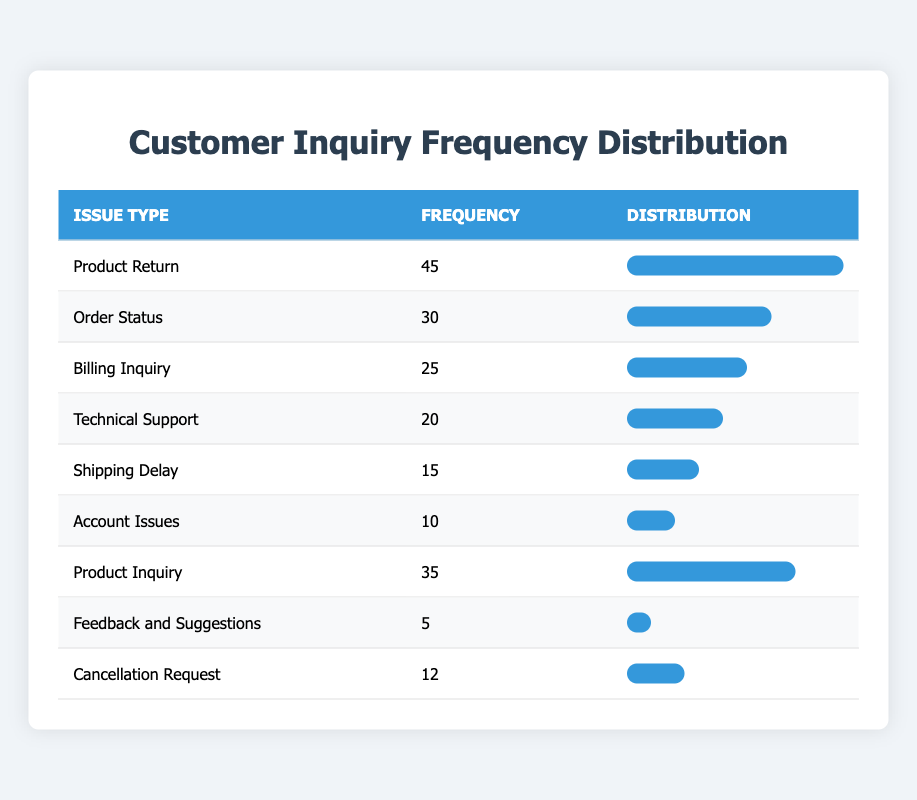What issue type has the highest frequency? By analyzing the table, we see that "Product Return" has a frequency of 45, which is the highest among all issue types listed.
Answer: Product Return How many inquiries were related to "Technical Support"? According to the table, "Technical Support" has a frequency of 20, which directly answers the question.
Answer: 20 What is the total frequency of all customer inquiries? To find the total frequency, we need to sum up all the frequencies: 45 + 30 + 25 + 20 + 15 + 10 + 35 + 5 + 12 = 192. Thus, the total frequency is 192.
Answer: 192 Is there a higher frequency of "Product Inquiry" than "Order Status"? The table indicates that "Product Inquiry" has a frequency of 35, while "Order Status" has a frequency of 30. Therefore, since 35 is greater than 30, the statement is true.
Answer: Yes What is the average frequency of all customer inquiries? There are nine inquiry types, and the total frequency is 192 (as calculated previously). To find the average, we divide the total frequency by the number of inquiry types: 192 / 9 = 21.33. Thus, the average frequency is 21.33.
Answer: 21.33 Which inquiry type had the lowest frequency, and what is that frequency? Looking at the table, we see that "Feedback and Suggestions" has the lowest frequency with a count of 5. This directly answers the question.
Answer: Feedback and Suggestions, 5 What percentage of total inquiries do "Cancellation Requests" represent? The frequency of "Cancellation Requests" is 12. To calculate its percentage of the total inquiries (192), we use the formula: (12/192) * 100 = 6.25%. Thus, "Cancellation Requests" account for 6.25% of total inquiries.
Answer: 6.25% How many more inquiries were there for "Product Return" than for "Shipping Delay"? From the table, "Product Return" has a frequency of 45, and "Shipping Delay" has a frequency of 15. The difference is 45 - 15 = 30. Therefore, there are 30 more inquiries for "Product Return".
Answer: 30 What is the difference in frequency between "Billing Inquiry" and "Account Issues"? "Billing Inquiry" has a frequency of 25 and "Account Issues" has a frequency of 10. The difference is 25 - 10 = 15. Thus, the frequency difference is 15.
Answer: 15 